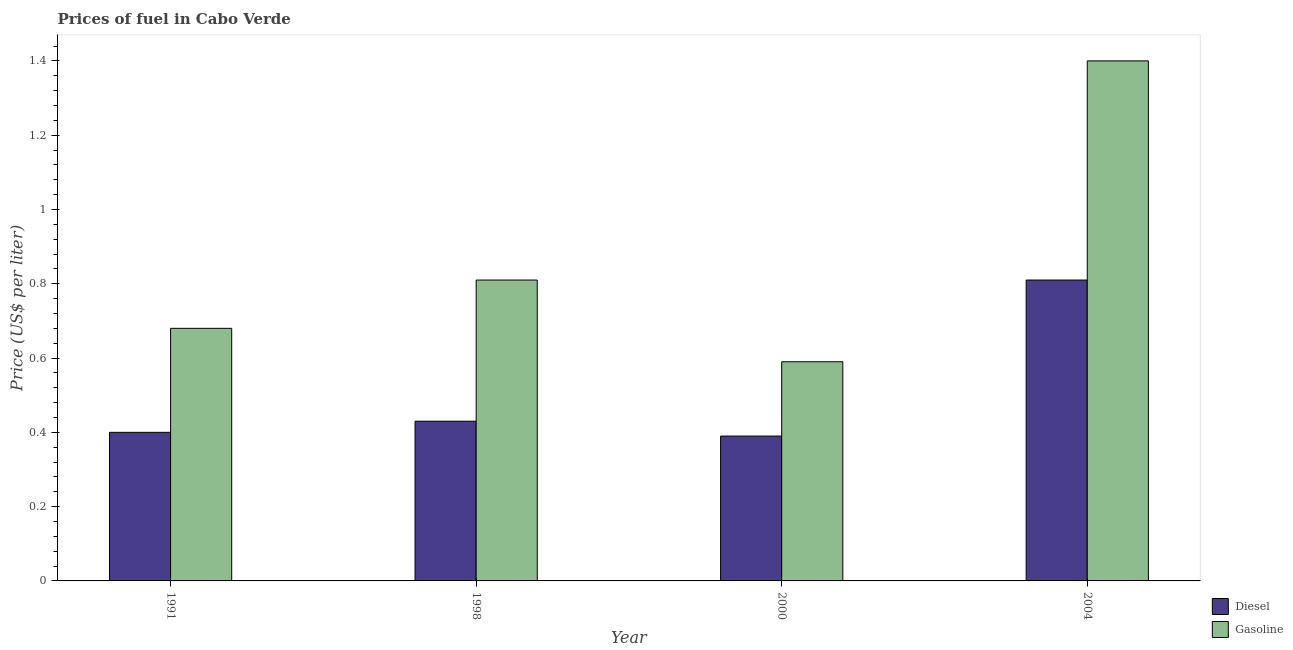How many different coloured bars are there?
Ensure brevity in your answer.  2. How many groups of bars are there?
Provide a short and direct response. 4. Are the number of bars per tick equal to the number of legend labels?
Keep it short and to the point. Yes. How many bars are there on the 1st tick from the left?
Give a very brief answer. 2. How many bars are there on the 2nd tick from the right?
Offer a terse response. 2. What is the label of the 4th group of bars from the left?
Provide a short and direct response. 2004. In how many cases, is the number of bars for a given year not equal to the number of legend labels?
Provide a succinct answer. 0. What is the gasoline price in 1998?
Provide a succinct answer. 0.81. Across all years, what is the maximum gasoline price?
Offer a very short reply. 1.4. Across all years, what is the minimum diesel price?
Make the answer very short. 0.39. What is the total diesel price in the graph?
Give a very brief answer. 2.03. What is the difference between the gasoline price in 2000 and that in 2004?
Your answer should be very brief. -0.81. What is the difference between the gasoline price in 2000 and the diesel price in 1991?
Offer a terse response. -0.09. What is the average diesel price per year?
Ensure brevity in your answer.  0.51. In how many years, is the gasoline price greater than 1.2000000000000002 US$ per litre?
Your answer should be compact. 1. What is the ratio of the diesel price in 1991 to that in 2000?
Keep it short and to the point. 1.03. Is the gasoline price in 1991 less than that in 2000?
Offer a very short reply. No. What is the difference between the highest and the second highest diesel price?
Provide a succinct answer. 0.38. What is the difference between the highest and the lowest gasoline price?
Your answer should be very brief. 0.81. In how many years, is the gasoline price greater than the average gasoline price taken over all years?
Your answer should be compact. 1. Is the sum of the diesel price in 1998 and 2000 greater than the maximum gasoline price across all years?
Keep it short and to the point. Yes. What does the 2nd bar from the left in 1991 represents?
Provide a short and direct response. Gasoline. What does the 2nd bar from the right in 1991 represents?
Offer a very short reply. Diesel. How many bars are there?
Offer a very short reply. 8. Are all the bars in the graph horizontal?
Make the answer very short. No. How many years are there in the graph?
Ensure brevity in your answer.  4. What is the difference between two consecutive major ticks on the Y-axis?
Your response must be concise. 0.2. Are the values on the major ticks of Y-axis written in scientific E-notation?
Give a very brief answer. No. How many legend labels are there?
Offer a terse response. 2. What is the title of the graph?
Provide a succinct answer. Prices of fuel in Cabo Verde. Does "Savings" appear as one of the legend labels in the graph?
Give a very brief answer. No. What is the label or title of the X-axis?
Your answer should be very brief. Year. What is the label or title of the Y-axis?
Make the answer very short. Price (US$ per liter). What is the Price (US$ per liter) of Diesel in 1991?
Your answer should be compact. 0.4. What is the Price (US$ per liter) of Gasoline in 1991?
Offer a terse response. 0.68. What is the Price (US$ per liter) of Diesel in 1998?
Make the answer very short. 0.43. What is the Price (US$ per liter) of Gasoline in 1998?
Your response must be concise. 0.81. What is the Price (US$ per liter) in Diesel in 2000?
Keep it short and to the point. 0.39. What is the Price (US$ per liter) of Gasoline in 2000?
Provide a short and direct response. 0.59. What is the Price (US$ per liter) of Diesel in 2004?
Your answer should be compact. 0.81. Across all years, what is the maximum Price (US$ per liter) in Diesel?
Offer a terse response. 0.81. Across all years, what is the minimum Price (US$ per liter) of Diesel?
Make the answer very short. 0.39. Across all years, what is the minimum Price (US$ per liter) of Gasoline?
Give a very brief answer. 0.59. What is the total Price (US$ per liter) in Diesel in the graph?
Your response must be concise. 2.03. What is the total Price (US$ per liter) of Gasoline in the graph?
Keep it short and to the point. 3.48. What is the difference between the Price (US$ per liter) of Diesel in 1991 and that in 1998?
Offer a terse response. -0.03. What is the difference between the Price (US$ per liter) in Gasoline in 1991 and that in 1998?
Offer a terse response. -0.13. What is the difference between the Price (US$ per liter) in Gasoline in 1991 and that in 2000?
Offer a terse response. 0.09. What is the difference between the Price (US$ per liter) of Diesel in 1991 and that in 2004?
Your answer should be compact. -0.41. What is the difference between the Price (US$ per liter) of Gasoline in 1991 and that in 2004?
Provide a succinct answer. -0.72. What is the difference between the Price (US$ per liter) of Diesel in 1998 and that in 2000?
Make the answer very short. 0.04. What is the difference between the Price (US$ per liter) of Gasoline in 1998 and that in 2000?
Your response must be concise. 0.22. What is the difference between the Price (US$ per liter) in Diesel in 1998 and that in 2004?
Keep it short and to the point. -0.38. What is the difference between the Price (US$ per liter) in Gasoline in 1998 and that in 2004?
Offer a very short reply. -0.59. What is the difference between the Price (US$ per liter) of Diesel in 2000 and that in 2004?
Provide a short and direct response. -0.42. What is the difference between the Price (US$ per liter) of Gasoline in 2000 and that in 2004?
Your answer should be very brief. -0.81. What is the difference between the Price (US$ per liter) in Diesel in 1991 and the Price (US$ per liter) in Gasoline in 1998?
Provide a succinct answer. -0.41. What is the difference between the Price (US$ per liter) of Diesel in 1991 and the Price (US$ per liter) of Gasoline in 2000?
Provide a short and direct response. -0.19. What is the difference between the Price (US$ per liter) in Diesel in 1991 and the Price (US$ per liter) in Gasoline in 2004?
Ensure brevity in your answer.  -1. What is the difference between the Price (US$ per liter) in Diesel in 1998 and the Price (US$ per liter) in Gasoline in 2000?
Provide a succinct answer. -0.16. What is the difference between the Price (US$ per liter) of Diesel in 1998 and the Price (US$ per liter) of Gasoline in 2004?
Make the answer very short. -0.97. What is the difference between the Price (US$ per liter) of Diesel in 2000 and the Price (US$ per liter) of Gasoline in 2004?
Provide a succinct answer. -1.01. What is the average Price (US$ per liter) in Diesel per year?
Your response must be concise. 0.51. What is the average Price (US$ per liter) of Gasoline per year?
Provide a short and direct response. 0.87. In the year 1991, what is the difference between the Price (US$ per liter) of Diesel and Price (US$ per liter) of Gasoline?
Provide a succinct answer. -0.28. In the year 1998, what is the difference between the Price (US$ per liter) in Diesel and Price (US$ per liter) in Gasoline?
Ensure brevity in your answer.  -0.38. In the year 2004, what is the difference between the Price (US$ per liter) in Diesel and Price (US$ per liter) in Gasoline?
Your answer should be very brief. -0.59. What is the ratio of the Price (US$ per liter) in Diesel in 1991 to that in 1998?
Provide a succinct answer. 0.93. What is the ratio of the Price (US$ per liter) of Gasoline in 1991 to that in 1998?
Offer a very short reply. 0.84. What is the ratio of the Price (US$ per liter) of Diesel in 1991 to that in 2000?
Your answer should be very brief. 1.03. What is the ratio of the Price (US$ per liter) of Gasoline in 1991 to that in 2000?
Your answer should be compact. 1.15. What is the ratio of the Price (US$ per liter) of Diesel in 1991 to that in 2004?
Give a very brief answer. 0.49. What is the ratio of the Price (US$ per liter) in Gasoline in 1991 to that in 2004?
Offer a very short reply. 0.49. What is the ratio of the Price (US$ per liter) of Diesel in 1998 to that in 2000?
Keep it short and to the point. 1.1. What is the ratio of the Price (US$ per liter) in Gasoline in 1998 to that in 2000?
Your answer should be very brief. 1.37. What is the ratio of the Price (US$ per liter) of Diesel in 1998 to that in 2004?
Offer a very short reply. 0.53. What is the ratio of the Price (US$ per liter) in Gasoline in 1998 to that in 2004?
Ensure brevity in your answer.  0.58. What is the ratio of the Price (US$ per liter) of Diesel in 2000 to that in 2004?
Offer a terse response. 0.48. What is the ratio of the Price (US$ per liter) in Gasoline in 2000 to that in 2004?
Give a very brief answer. 0.42. What is the difference between the highest and the second highest Price (US$ per liter) in Diesel?
Ensure brevity in your answer.  0.38. What is the difference between the highest and the second highest Price (US$ per liter) in Gasoline?
Provide a succinct answer. 0.59. What is the difference between the highest and the lowest Price (US$ per liter) in Diesel?
Provide a succinct answer. 0.42. What is the difference between the highest and the lowest Price (US$ per liter) in Gasoline?
Your response must be concise. 0.81. 